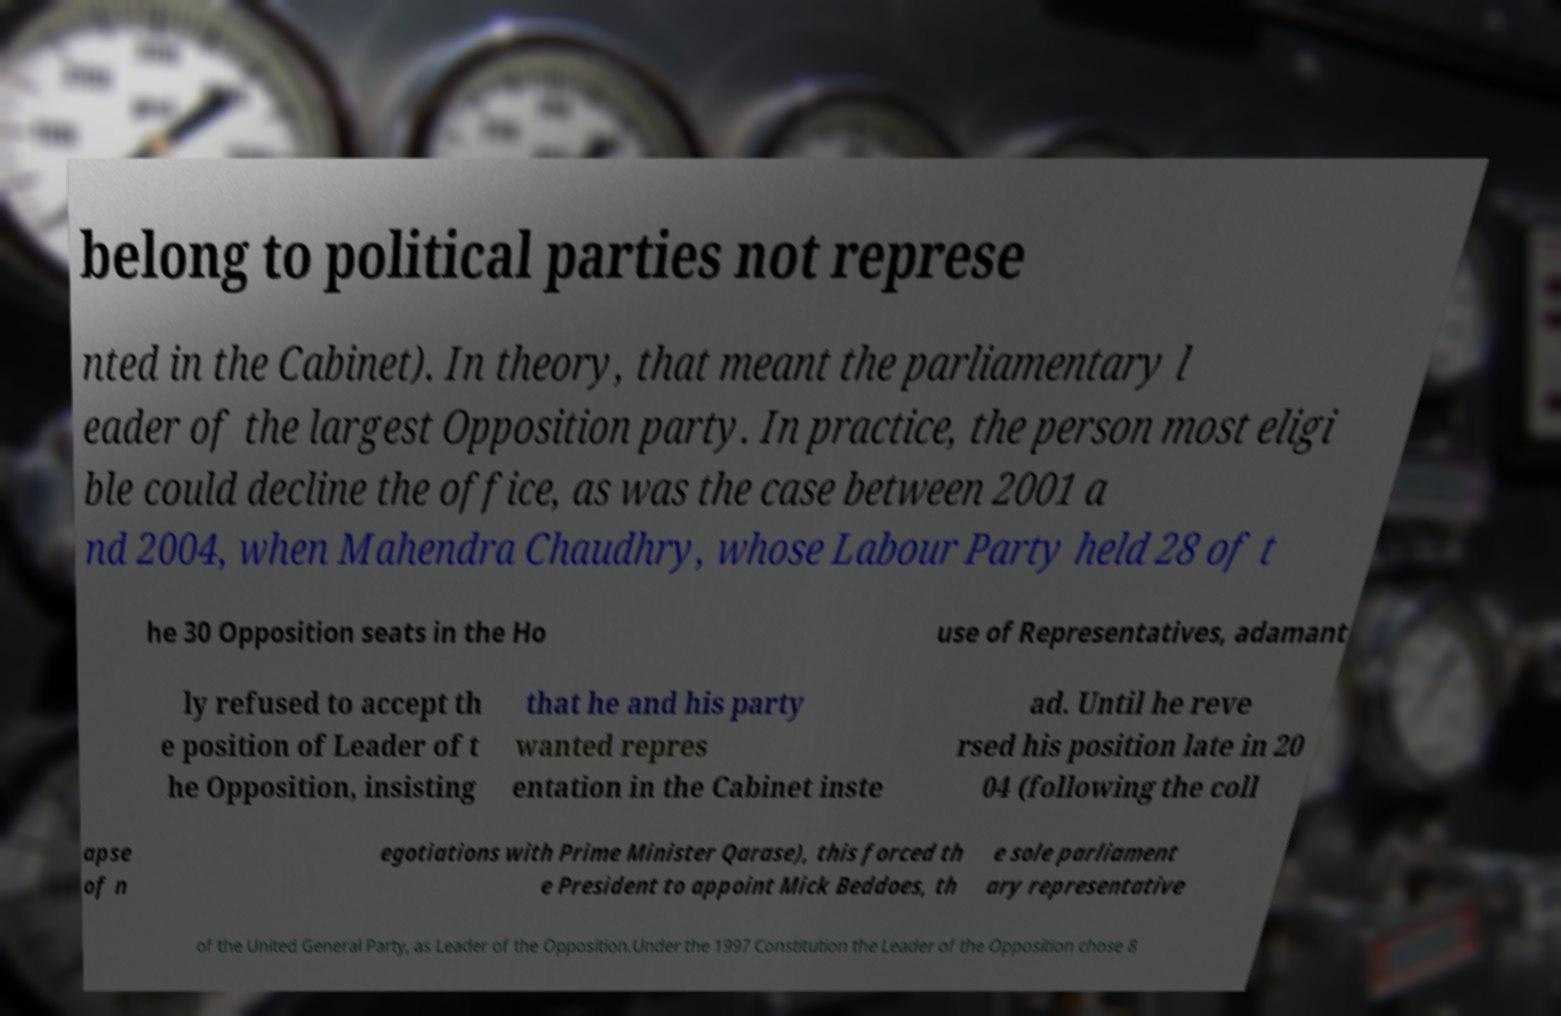Could you assist in decoding the text presented in this image and type it out clearly? belong to political parties not represe nted in the Cabinet). In theory, that meant the parliamentary l eader of the largest Opposition party. In practice, the person most eligi ble could decline the office, as was the case between 2001 a nd 2004, when Mahendra Chaudhry, whose Labour Party held 28 of t he 30 Opposition seats in the Ho use of Representatives, adamant ly refused to accept th e position of Leader of t he Opposition, insisting that he and his party wanted repres entation in the Cabinet inste ad. Until he reve rsed his position late in 20 04 (following the coll apse of n egotiations with Prime Minister Qarase), this forced th e President to appoint Mick Beddoes, th e sole parliament ary representative of the United General Party, as Leader of the Opposition.Under the 1997 Constitution the Leader of the Opposition chose 8 